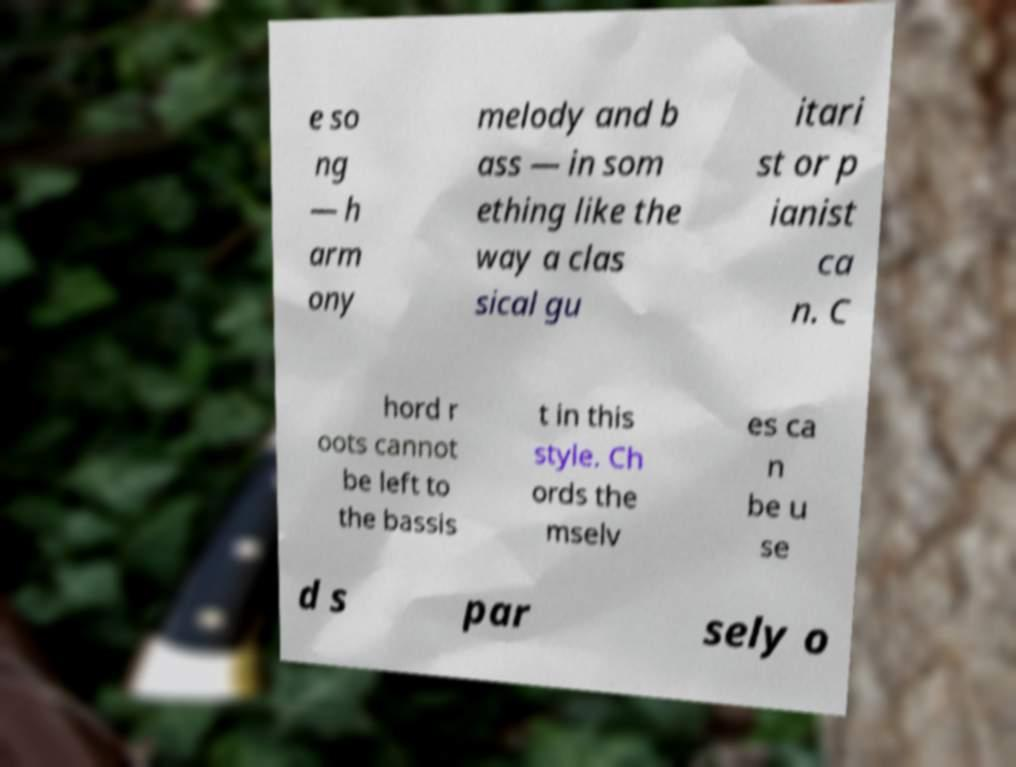Please read and relay the text visible in this image. What does it say? e so ng — h arm ony melody and b ass — in som ething like the way a clas sical gu itari st or p ianist ca n. C hord r oots cannot be left to the bassis t in this style. Ch ords the mselv es ca n be u se d s par sely o 